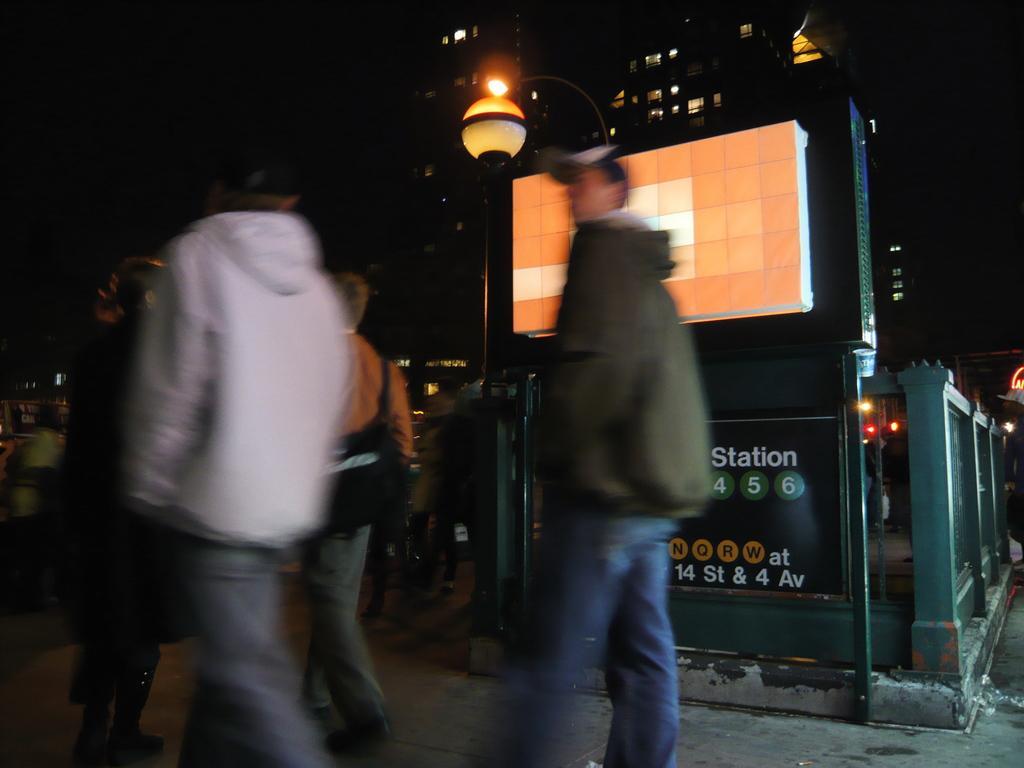Describe this image in one or two sentences. This is the blurred picture of a some people on the road and to the side there is a fencing, board, poles which has a lamp and also we can see some buildings to which there are some lights. 